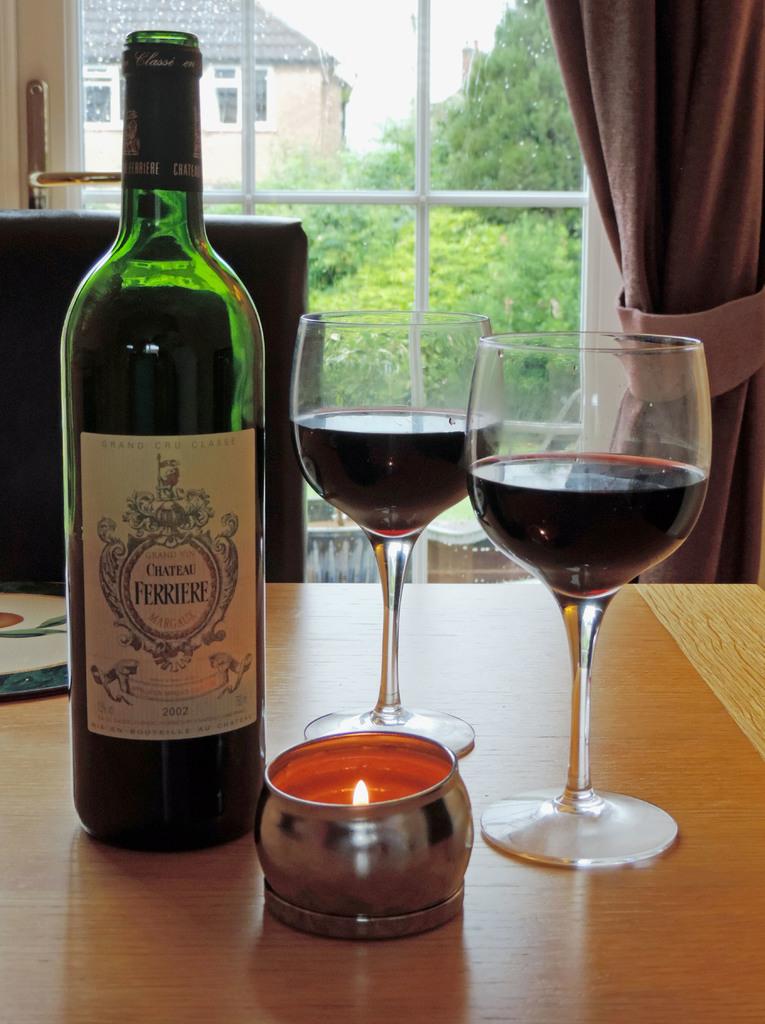What is the name of this brand of wine?
Your answer should be compact. Ferriere. 